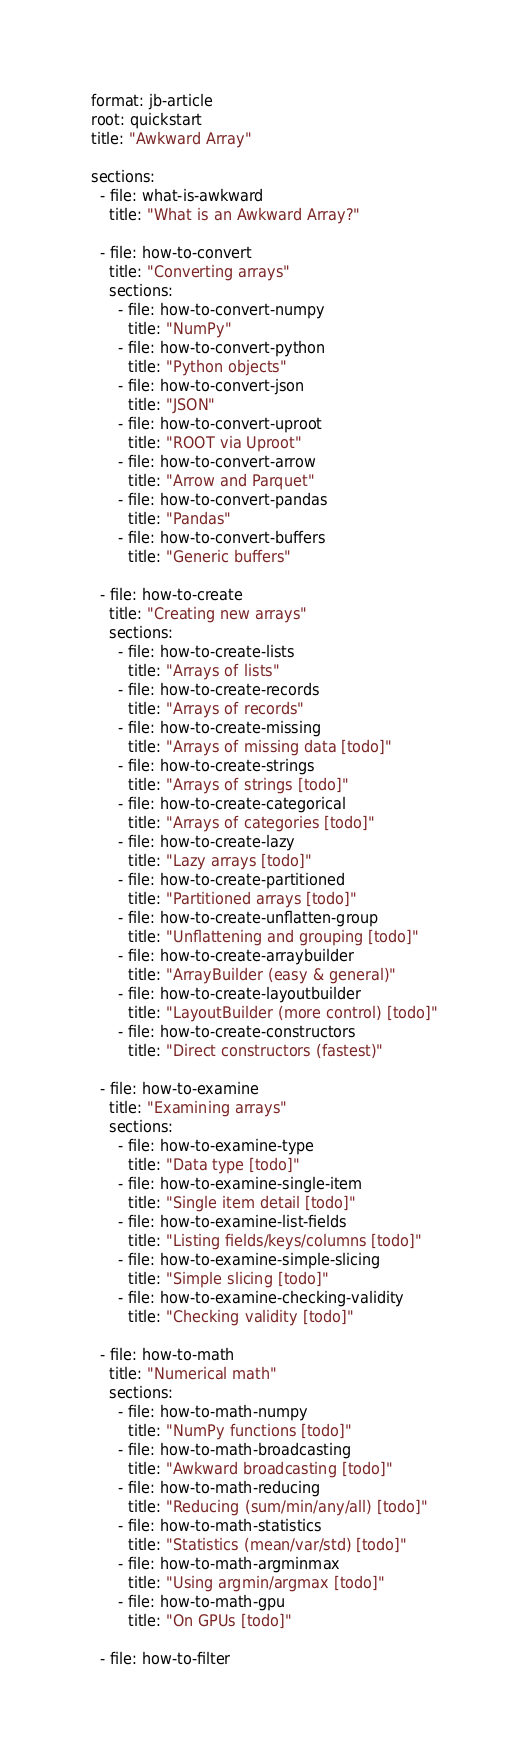<code> <loc_0><loc_0><loc_500><loc_500><_YAML_>format: jb-article
root: quickstart
title: "Awkward Array"

sections:
  - file: what-is-awkward
    title: "What is an Awkward Array?"

  - file: how-to-convert
    title: "Converting arrays"
    sections:
      - file: how-to-convert-numpy
        title: "NumPy"
      - file: how-to-convert-python
        title: "Python objects"
      - file: how-to-convert-json
        title: "JSON"
      - file: how-to-convert-uproot
        title: "ROOT via Uproot"
      - file: how-to-convert-arrow
        title: "Arrow and Parquet"
      - file: how-to-convert-pandas
        title: "Pandas"
      - file: how-to-convert-buffers
        title: "Generic buffers"

  - file: how-to-create
    title: "Creating new arrays"
    sections:
      - file: how-to-create-lists
        title: "Arrays of lists"
      - file: how-to-create-records
        title: "Arrays of records"
      - file: how-to-create-missing
        title: "Arrays of missing data [todo]"
      - file: how-to-create-strings
        title: "Arrays of strings [todo]"
      - file: how-to-create-categorical
        title: "Arrays of categories [todo]"
      - file: how-to-create-lazy
        title: "Lazy arrays [todo]"
      - file: how-to-create-partitioned
        title: "Partitioned arrays [todo]"
      - file: how-to-create-unflatten-group
        title: "Unflattening and grouping [todo]"
      - file: how-to-create-arraybuilder
        title: "ArrayBuilder (easy & general)"
      - file: how-to-create-layoutbuilder
        title: "LayoutBuilder (more control) [todo]"
      - file: how-to-create-constructors
        title: "Direct constructors (fastest)"

  - file: how-to-examine
    title: "Examining arrays"
    sections:
      - file: how-to-examine-type
        title: "Data type [todo]"
      - file: how-to-examine-single-item
        title: "Single item detail [todo]"
      - file: how-to-examine-list-fields
        title: "Listing fields/keys/columns [todo]"
      - file: how-to-examine-simple-slicing
        title: "Simple slicing [todo]"
      - file: how-to-examine-checking-validity
        title: "Checking validity [todo]"

  - file: how-to-math
    title: "Numerical math"
    sections:
      - file: how-to-math-numpy
        title: "NumPy functions [todo]"
      - file: how-to-math-broadcasting
        title: "Awkward broadcasting [todo]"
      - file: how-to-math-reducing
        title: "Reducing (sum/min/any/all) [todo]"
      - file: how-to-math-statistics
        title: "Statistics (mean/var/std) [todo]"
      - file: how-to-math-argminmax
        title: "Using argmin/argmax [todo]"
      - file: how-to-math-gpu
        title: "On GPUs [todo]"

  - file: how-to-filter</code> 